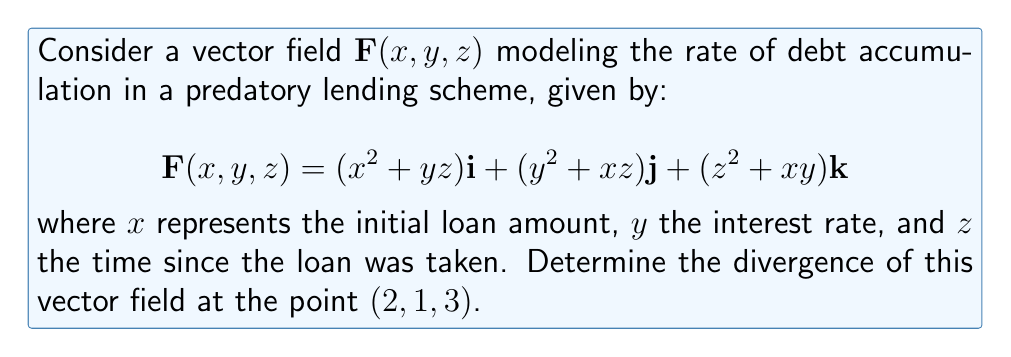Give your solution to this math problem. To find the divergence of the vector field $\mathbf{F}(x,y,z)$, we need to calculate:

$$\text{div}\mathbf{F} = \nabla \cdot \mathbf{F} = \frac{\partial F_x}{\partial x} + \frac{\partial F_y}{\partial y} + \frac{\partial F_z}{\partial z}$$

Let's break it down step by step:

1) First, let's identify each component of $\mathbf{F}$:
   $F_x = x^2 + yz$
   $F_y = y^2 + xz$
   $F_z = z^2 + xy$

2) Now, let's calculate each partial derivative:

   $\frac{\partial F_x}{\partial x} = 2x$
   
   $\frac{\partial F_y}{\partial y} = 2y$
   
   $\frac{\partial F_z}{\partial z} = 2z$

3) The divergence is the sum of these partial derivatives:

   $$\text{div}\mathbf{F} = 2x + 2y + 2z$$

4) To find the divergence at the point (2, 1, 3), we substitute these values:

   $$\text{div}\mathbf{F}(2,1,3) = 2(2) + 2(1) + 2(3) = 4 + 2 + 6 = 12$$

Therefore, the divergence of the vector field at the point (2, 1, 3) is 12.
Answer: 12 